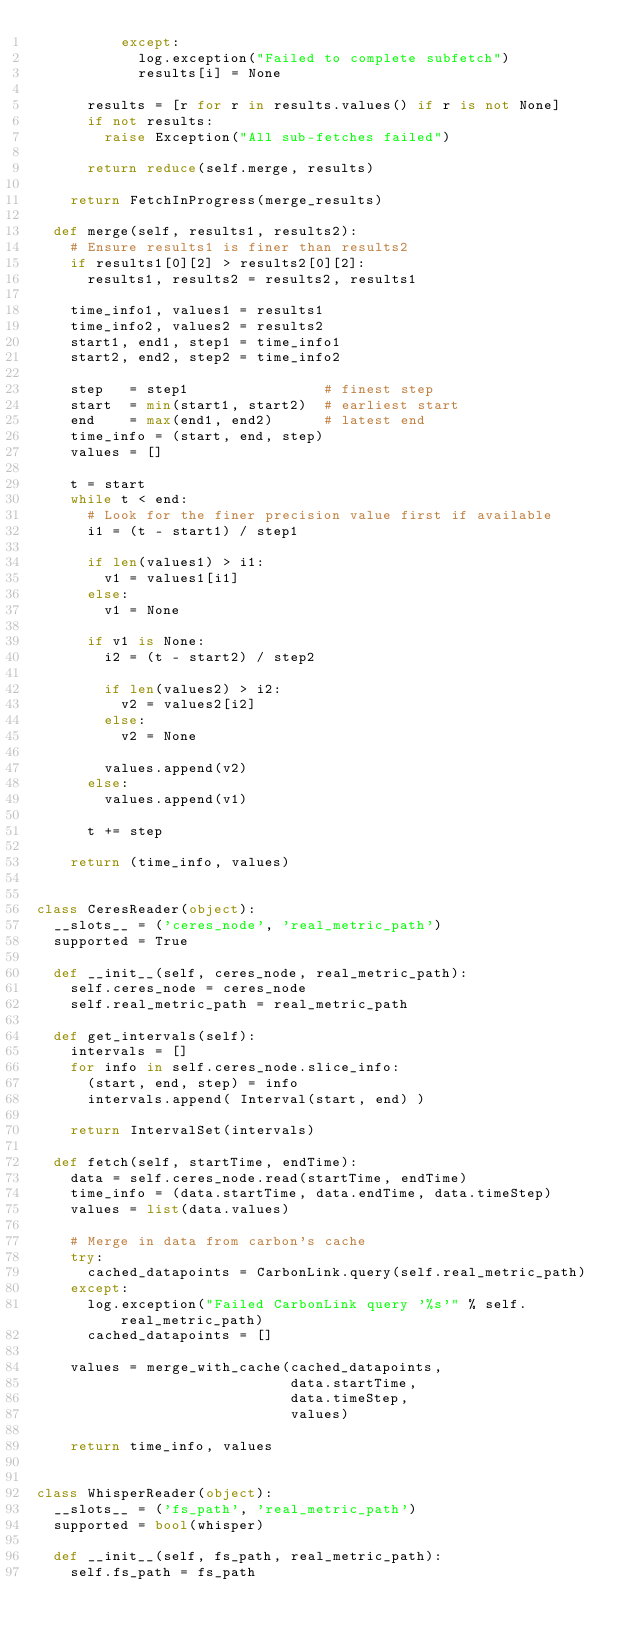<code> <loc_0><loc_0><loc_500><loc_500><_Python_>          except:
            log.exception("Failed to complete subfetch")
            results[i] = None

      results = [r for r in results.values() if r is not None]
      if not results:
        raise Exception("All sub-fetches failed")

      return reduce(self.merge, results)

    return FetchInProgress(merge_results)

  def merge(self, results1, results2):
    # Ensure results1 is finer than results2
    if results1[0][2] > results2[0][2]:
      results1, results2 = results2, results1

    time_info1, values1 = results1
    time_info2, values2 = results2
    start1, end1, step1 = time_info1
    start2, end2, step2 = time_info2

    step   = step1                # finest step
    start  = min(start1, start2)  # earliest start
    end    = max(end1, end2)      # latest end
    time_info = (start, end, step)
    values = []

    t = start
    while t < end:
      # Look for the finer precision value first if available
      i1 = (t - start1) / step1

      if len(values1) > i1:
        v1 = values1[i1]
      else:
        v1 = None

      if v1 is None:
        i2 = (t - start2) / step2

        if len(values2) > i2:
          v2 = values2[i2]
        else:
          v2 = None

        values.append(v2)
      else:
        values.append(v1)

      t += step

    return (time_info, values)


class CeresReader(object):
  __slots__ = ('ceres_node', 'real_metric_path')
  supported = True

  def __init__(self, ceres_node, real_metric_path):
    self.ceres_node = ceres_node
    self.real_metric_path = real_metric_path

  def get_intervals(self):
    intervals = []
    for info in self.ceres_node.slice_info:
      (start, end, step) = info
      intervals.append( Interval(start, end) )

    return IntervalSet(intervals)

  def fetch(self, startTime, endTime):
    data = self.ceres_node.read(startTime, endTime)
    time_info = (data.startTime, data.endTime, data.timeStep)
    values = list(data.values)

    # Merge in data from carbon's cache
    try:
      cached_datapoints = CarbonLink.query(self.real_metric_path)
    except:
      log.exception("Failed CarbonLink query '%s'" % self.real_metric_path)
      cached_datapoints = []

    values = merge_with_cache(cached_datapoints,
                              data.startTime,
                              data.timeStep,
                              values)

    return time_info, values


class WhisperReader(object):
  __slots__ = ('fs_path', 'real_metric_path')
  supported = bool(whisper)

  def __init__(self, fs_path, real_metric_path):
    self.fs_path = fs_path</code> 